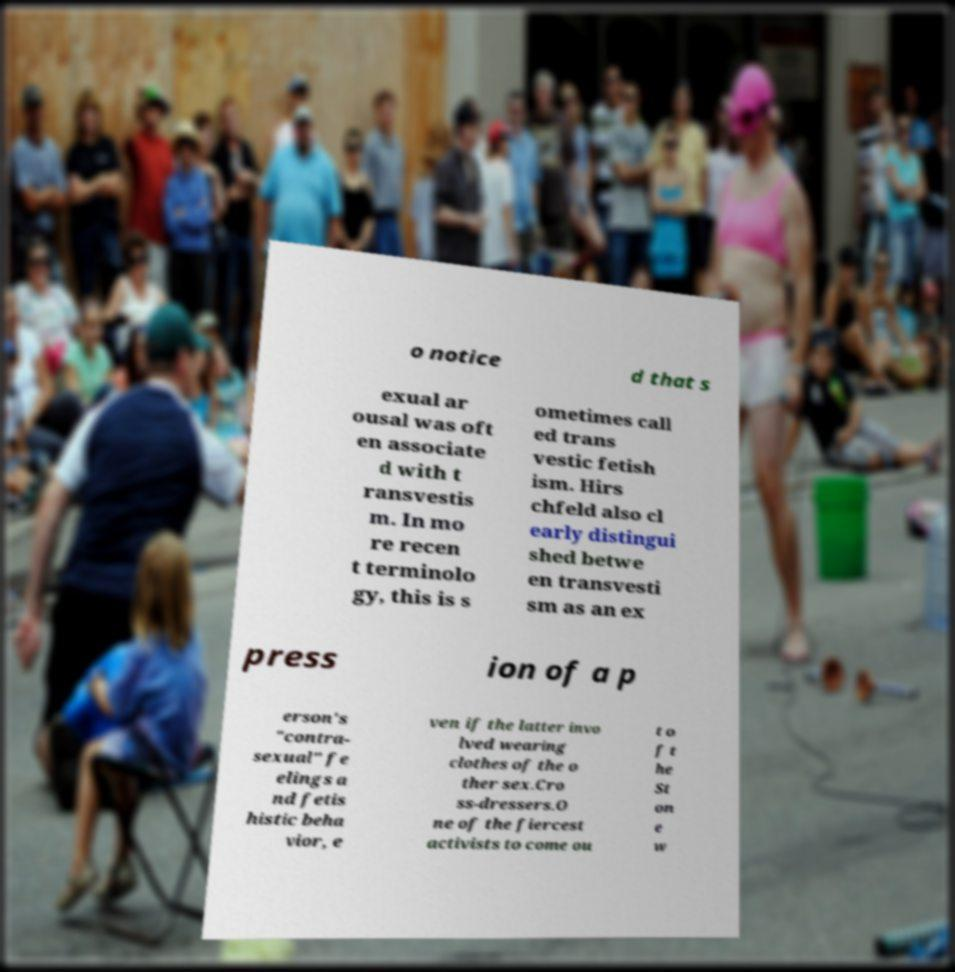Could you extract and type out the text from this image? o notice d that s exual ar ousal was oft en associate d with t ransvestis m. In mo re recen t terminolo gy, this is s ometimes call ed trans vestic fetish ism. Hirs chfeld also cl early distingui shed betwe en transvesti sm as an ex press ion of a p erson's "contra- sexual" fe elings a nd fetis histic beha vior, e ven if the latter invo lved wearing clothes of the o ther sex.Cro ss-dressers.O ne of the fiercest activists to come ou t o f t he St on e w 